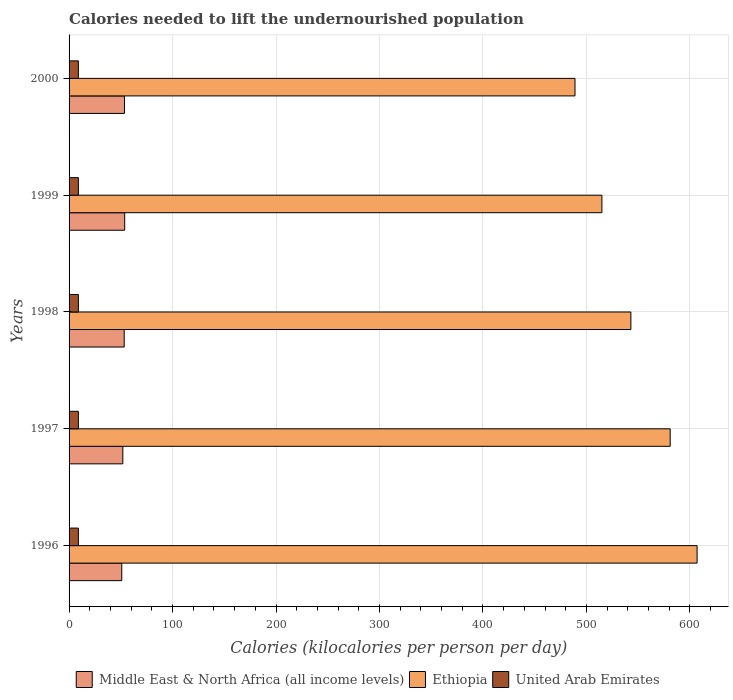Are the number of bars per tick equal to the number of legend labels?
Provide a short and direct response. Yes. Are the number of bars on each tick of the Y-axis equal?
Give a very brief answer. Yes. How many bars are there on the 4th tick from the top?
Keep it short and to the point. 3. What is the label of the 3rd group of bars from the top?
Make the answer very short. 1998. In how many cases, is the number of bars for a given year not equal to the number of legend labels?
Provide a short and direct response. 0. What is the total calories needed to lift the undernourished population in Ethiopia in 1998?
Keep it short and to the point. 543. Across all years, what is the maximum total calories needed to lift the undernourished population in United Arab Emirates?
Keep it short and to the point. 9. Across all years, what is the minimum total calories needed to lift the undernourished population in Middle East & North Africa (all income levels)?
Offer a terse response. 50.92. In which year was the total calories needed to lift the undernourished population in Middle East & North Africa (all income levels) minimum?
Your answer should be very brief. 1996. What is the total total calories needed to lift the undernourished population in United Arab Emirates in the graph?
Give a very brief answer. 45. What is the difference between the total calories needed to lift the undernourished population in Middle East & North Africa (all income levels) in 1997 and that in 1998?
Keep it short and to the point. -1.33. What is the difference between the total calories needed to lift the undernourished population in Ethiopia in 1998 and the total calories needed to lift the undernourished population in Middle East & North Africa (all income levels) in 1999?
Keep it short and to the point. 489.25. In the year 1997, what is the difference between the total calories needed to lift the undernourished population in Middle East & North Africa (all income levels) and total calories needed to lift the undernourished population in United Arab Emirates?
Your answer should be compact. 42.96. In how many years, is the total calories needed to lift the undernourished population in United Arab Emirates greater than 300 kilocalories?
Your answer should be compact. 0. What is the ratio of the total calories needed to lift the undernourished population in Middle East & North Africa (all income levels) in 1997 to that in 1998?
Your answer should be compact. 0.98. Is the total calories needed to lift the undernourished population in Middle East & North Africa (all income levels) in 1997 less than that in 1999?
Keep it short and to the point. Yes. Is the difference between the total calories needed to lift the undernourished population in Middle East & North Africa (all income levels) in 1997 and 2000 greater than the difference between the total calories needed to lift the undernourished population in United Arab Emirates in 1997 and 2000?
Your response must be concise. No. What is the difference between the highest and the second highest total calories needed to lift the undernourished population in Middle East & North Africa (all income levels)?
Your answer should be compact. 0.19. What is the difference between the highest and the lowest total calories needed to lift the undernourished population in Middle East & North Africa (all income levels)?
Keep it short and to the point. 2.83. What does the 3rd bar from the top in 1998 represents?
Ensure brevity in your answer.  Middle East & North Africa (all income levels). What does the 1st bar from the bottom in 2000 represents?
Provide a succinct answer. Middle East & North Africa (all income levels). Is it the case that in every year, the sum of the total calories needed to lift the undernourished population in Ethiopia and total calories needed to lift the undernourished population in Middle East & North Africa (all income levels) is greater than the total calories needed to lift the undernourished population in United Arab Emirates?
Offer a terse response. Yes. What is the difference between two consecutive major ticks on the X-axis?
Your answer should be compact. 100. Does the graph contain any zero values?
Your answer should be compact. No. How many legend labels are there?
Give a very brief answer. 3. How are the legend labels stacked?
Offer a terse response. Horizontal. What is the title of the graph?
Ensure brevity in your answer.  Calories needed to lift the undernourished population. Does "High income: nonOECD" appear as one of the legend labels in the graph?
Ensure brevity in your answer.  No. What is the label or title of the X-axis?
Keep it short and to the point. Calories (kilocalories per person per day). What is the Calories (kilocalories per person per day) of Middle East & North Africa (all income levels) in 1996?
Your response must be concise. 50.92. What is the Calories (kilocalories per person per day) in Ethiopia in 1996?
Your response must be concise. 607. What is the Calories (kilocalories per person per day) in United Arab Emirates in 1996?
Keep it short and to the point. 9. What is the Calories (kilocalories per person per day) of Middle East & North Africa (all income levels) in 1997?
Your response must be concise. 51.96. What is the Calories (kilocalories per person per day) of Ethiopia in 1997?
Your answer should be compact. 581. What is the Calories (kilocalories per person per day) of United Arab Emirates in 1997?
Your answer should be very brief. 9. What is the Calories (kilocalories per person per day) of Middle East & North Africa (all income levels) in 1998?
Keep it short and to the point. 53.29. What is the Calories (kilocalories per person per day) in Ethiopia in 1998?
Keep it short and to the point. 543. What is the Calories (kilocalories per person per day) in Middle East & North Africa (all income levels) in 1999?
Provide a short and direct response. 53.75. What is the Calories (kilocalories per person per day) of Ethiopia in 1999?
Your answer should be compact. 515. What is the Calories (kilocalories per person per day) in United Arab Emirates in 1999?
Keep it short and to the point. 9. What is the Calories (kilocalories per person per day) of Middle East & North Africa (all income levels) in 2000?
Give a very brief answer. 53.56. What is the Calories (kilocalories per person per day) of Ethiopia in 2000?
Offer a very short reply. 489. What is the Calories (kilocalories per person per day) in United Arab Emirates in 2000?
Keep it short and to the point. 9. Across all years, what is the maximum Calories (kilocalories per person per day) of Middle East & North Africa (all income levels)?
Give a very brief answer. 53.75. Across all years, what is the maximum Calories (kilocalories per person per day) of Ethiopia?
Offer a terse response. 607. Across all years, what is the maximum Calories (kilocalories per person per day) in United Arab Emirates?
Ensure brevity in your answer.  9. Across all years, what is the minimum Calories (kilocalories per person per day) of Middle East & North Africa (all income levels)?
Make the answer very short. 50.92. Across all years, what is the minimum Calories (kilocalories per person per day) in Ethiopia?
Make the answer very short. 489. Across all years, what is the minimum Calories (kilocalories per person per day) in United Arab Emirates?
Keep it short and to the point. 9. What is the total Calories (kilocalories per person per day) of Middle East & North Africa (all income levels) in the graph?
Your response must be concise. 263.48. What is the total Calories (kilocalories per person per day) of Ethiopia in the graph?
Make the answer very short. 2735. What is the total Calories (kilocalories per person per day) of United Arab Emirates in the graph?
Your answer should be very brief. 45. What is the difference between the Calories (kilocalories per person per day) in Middle East & North Africa (all income levels) in 1996 and that in 1997?
Your answer should be very brief. -1.04. What is the difference between the Calories (kilocalories per person per day) in Ethiopia in 1996 and that in 1997?
Give a very brief answer. 26. What is the difference between the Calories (kilocalories per person per day) in United Arab Emirates in 1996 and that in 1997?
Offer a terse response. 0. What is the difference between the Calories (kilocalories per person per day) of Middle East & North Africa (all income levels) in 1996 and that in 1998?
Provide a short and direct response. -2.36. What is the difference between the Calories (kilocalories per person per day) of Middle East & North Africa (all income levels) in 1996 and that in 1999?
Ensure brevity in your answer.  -2.83. What is the difference between the Calories (kilocalories per person per day) of Ethiopia in 1996 and that in 1999?
Provide a short and direct response. 92. What is the difference between the Calories (kilocalories per person per day) in Middle East & North Africa (all income levels) in 1996 and that in 2000?
Ensure brevity in your answer.  -2.63. What is the difference between the Calories (kilocalories per person per day) of Ethiopia in 1996 and that in 2000?
Ensure brevity in your answer.  118. What is the difference between the Calories (kilocalories per person per day) of United Arab Emirates in 1996 and that in 2000?
Ensure brevity in your answer.  0. What is the difference between the Calories (kilocalories per person per day) in Middle East & North Africa (all income levels) in 1997 and that in 1998?
Your response must be concise. -1.33. What is the difference between the Calories (kilocalories per person per day) in United Arab Emirates in 1997 and that in 1998?
Provide a succinct answer. 0. What is the difference between the Calories (kilocalories per person per day) of Middle East & North Africa (all income levels) in 1997 and that in 1999?
Give a very brief answer. -1.79. What is the difference between the Calories (kilocalories per person per day) in Ethiopia in 1997 and that in 1999?
Your response must be concise. 66. What is the difference between the Calories (kilocalories per person per day) in United Arab Emirates in 1997 and that in 1999?
Ensure brevity in your answer.  0. What is the difference between the Calories (kilocalories per person per day) of Middle East & North Africa (all income levels) in 1997 and that in 2000?
Offer a very short reply. -1.6. What is the difference between the Calories (kilocalories per person per day) in Ethiopia in 1997 and that in 2000?
Provide a succinct answer. 92. What is the difference between the Calories (kilocalories per person per day) in United Arab Emirates in 1997 and that in 2000?
Your answer should be very brief. 0. What is the difference between the Calories (kilocalories per person per day) of Middle East & North Africa (all income levels) in 1998 and that in 1999?
Keep it short and to the point. -0.46. What is the difference between the Calories (kilocalories per person per day) of Middle East & North Africa (all income levels) in 1998 and that in 2000?
Ensure brevity in your answer.  -0.27. What is the difference between the Calories (kilocalories per person per day) of United Arab Emirates in 1998 and that in 2000?
Your response must be concise. 0. What is the difference between the Calories (kilocalories per person per day) of Middle East & North Africa (all income levels) in 1999 and that in 2000?
Provide a short and direct response. 0.19. What is the difference between the Calories (kilocalories per person per day) in Ethiopia in 1999 and that in 2000?
Your response must be concise. 26. What is the difference between the Calories (kilocalories per person per day) of Middle East & North Africa (all income levels) in 1996 and the Calories (kilocalories per person per day) of Ethiopia in 1997?
Offer a terse response. -530.08. What is the difference between the Calories (kilocalories per person per day) in Middle East & North Africa (all income levels) in 1996 and the Calories (kilocalories per person per day) in United Arab Emirates in 1997?
Your response must be concise. 41.92. What is the difference between the Calories (kilocalories per person per day) of Ethiopia in 1996 and the Calories (kilocalories per person per day) of United Arab Emirates in 1997?
Offer a very short reply. 598. What is the difference between the Calories (kilocalories per person per day) in Middle East & North Africa (all income levels) in 1996 and the Calories (kilocalories per person per day) in Ethiopia in 1998?
Your answer should be compact. -492.08. What is the difference between the Calories (kilocalories per person per day) in Middle East & North Africa (all income levels) in 1996 and the Calories (kilocalories per person per day) in United Arab Emirates in 1998?
Ensure brevity in your answer.  41.92. What is the difference between the Calories (kilocalories per person per day) in Ethiopia in 1996 and the Calories (kilocalories per person per day) in United Arab Emirates in 1998?
Your answer should be very brief. 598. What is the difference between the Calories (kilocalories per person per day) in Middle East & North Africa (all income levels) in 1996 and the Calories (kilocalories per person per day) in Ethiopia in 1999?
Your answer should be compact. -464.08. What is the difference between the Calories (kilocalories per person per day) of Middle East & North Africa (all income levels) in 1996 and the Calories (kilocalories per person per day) of United Arab Emirates in 1999?
Provide a short and direct response. 41.92. What is the difference between the Calories (kilocalories per person per day) in Ethiopia in 1996 and the Calories (kilocalories per person per day) in United Arab Emirates in 1999?
Your response must be concise. 598. What is the difference between the Calories (kilocalories per person per day) in Middle East & North Africa (all income levels) in 1996 and the Calories (kilocalories per person per day) in Ethiopia in 2000?
Ensure brevity in your answer.  -438.08. What is the difference between the Calories (kilocalories per person per day) in Middle East & North Africa (all income levels) in 1996 and the Calories (kilocalories per person per day) in United Arab Emirates in 2000?
Ensure brevity in your answer.  41.92. What is the difference between the Calories (kilocalories per person per day) in Ethiopia in 1996 and the Calories (kilocalories per person per day) in United Arab Emirates in 2000?
Make the answer very short. 598. What is the difference between the Calories (kilocalories per person per day) of Middle East & North Africa (all income levels) in 1997 and the Calories (kilocalories per person per day) of Ethiopia in 1998?
Your answer should be very brief. -491.04. What is the difference between the Calories (kilocalories per person per day) of Middle East & North Africa (all income levels) in 1997 and the Calories (kilocalories per person per day) of United Arab Emirates in 1998?
Give a very brief answer. 42.96. What is the difference between the Calories (kilocalories per person per day) of Ethiopia in 1997 and the Calories (kilocalories per person per day) of United Arab Emirates in 1998?
Your response must be concise. 572. What is the difference between the Calories (kilocalories per person per day) in Middle East & North Africa (all income levels) in 1997 and the Calories (kilocalories per person per day) in Ethiopia in 1999?
Keep it short and to the point. -463.04. What is the difference between the Calories (kilocalories per person per day) in Middle East & North Africa (all income levels) in 1997 and the Calories (kilocalories per person per day) in United Arab Emirates in 1999?
Keep it short and to the point. 42.96. What is the difference between the Calories (kilocalories per person per day) in Ethiopia in 1997 and the Calories (kilocalories per person per day) in United Arab Emirates in 1999?
Make the answer very short. 572. What is the difference between the Calories (kilocalories per person per day) of Middle East & North Africa (all income levels) in 1997 and the Calories (kilocalories per person per day) of Ethiopia in 2000?
Your response must be concise. -437.04. What is the difference between the Calories (kilocalories per person per day) in Middle East & North Africa (all income levels) in 1997 and the Calories (kilocalories per person per day) in United Arab Emirates in 2000?
Ensure brevity in your answer.  42.96. What is the difference between the Calories (kilocalories per person per day) of Ethiopia in 1997 and the Calories (kilocalories per person per day) of United Arab Emirates in 2000?
Your answer should be compact. 572. What is the difference between the Calories (kilocalories per person per day) in Middle East & North Africa (all income levels) in 1998 and the Calories (kilocalories per person per day) in Ethiopia in 1999?
Make the answer very short. -461.71. What is the difference between the Calories (kilocalories per person per day) of Middle East & North Africa (all income levels) in 1998 and the Calories (kilocalories per person per day) of United Arab Emirates in 1999?
Ensure brevity in your answer.  44.29. What is the difference between the Calories (kilocalories per person per day) in Ethiopia in 1998 and the Calories (kilocalories per person per day) in United Arab Emirates in 1999?
Offer a very short reply. 534. What is the difference between the Calories (kilocalories per person per day) of Middle East & North Africa (all income levels) in 1998 and the Calories (kilocalories per person per day) of Ethiopia in 2000?
Keep it short and to the point. -435.71. What is the difference between the Calories (kilocalories per person per day) in Middle East & North Africa (all income levels) in 1998 and the Calories (kilocalories per person per day) in United Arab Emirates in 2000?
Offer a terse response. 44.29. What is the difference between the Calories (kilocalories per person per day) in Ethiopia in 1998 and the Calories (kilocalories per person per day) in United Arab Emirates in 2000?
Offer a terse response. 534. What is the difference between the Calories (kilocalories per person per day) of Middle East & North Africa (all income levels) in 1999 and the Calories (kilocalories per person per day) of Ethiopia in 2000?
Offer a very short reply. -435.25. What is the difference between the Calories (kilocalories per person per day) of Middle East & North Africa (all income levels) in 1999 and the Calories (kilocalories per person per day) of United Arab Emirates in 2000?
Your answer should be very brief. 44.75. What is the difference between the Calories (kilocalories per person per day) in Ethiopia in 1999 and the Calories (kilocalories per person per day) in United Arab Emirates in 2000?
Provide a short and direct response. 506. What is the average Calories (kilocalories per person per day) in Middle East & North Africa (all income levels) per year?
Offer a very short reply. 52.7. What is the average Calories (kilocalories per person per day) in Ethiopia per year?
Provide a short and direct response. 547. In the year 1996, what is the difference between the Calories (kilocalories per person per day) of Middle East & North Africa (all income levels) and Calories (kilocalories per person per day) of Ethiopia?
Keep it short and to the point. -556.08. In the year 1996, what is the difference between the Calories (kilocalories per person per day) of Middle East & North Africa (all income levels) and Calories (kilocalories per person per day) of United Arab Emirates?
Provide a succinct answer. 41.92. In the year 1996, what is the difference between the Calories (kilocalories per person per day) of Ethiopia and Calories (kilocalories per person per day) of United Arab Emirates?
Offer a very short reply. 598. In the year 1997, what is the difference between the Calories (kilocalories per person per day) in Middle East & North Africa (all income levels) and Calories (kilocalories per person per day) in Ethiopia?
Keep it short and to the point. -529.04. In the year 1997, what is the difference between the Calories (kilocalories per person per day) in Middle East & North Africa (all income levels) and Calories (kilocalories per person per day) in United Arab Emirates?
Provide a short and direct response. 42.96. In the year 1997, what is the difference between the Calories (kilocalories per person per day) in Ethiopia and Calories (kilocalories per person per day) in United Arab Emirates?
Provide a succinct answer. 572. In the year 1998, what is the difference between the Calories (kilocalories per person per day) of Middle East & North Africa (all income levels) and Calories (kilocalories per person per day) of Ethiopia?
Offer a very short reply. -489.71. In the year 1998, what is the difference between the Calories (kilocalories per person per day) of Middle East & North Africa (all income levels) and Calories (kilocalories per person per day) of United Arab Emirates?
Make the answer very short. 44.29. In the year 1998, what is the difference between the Calories (kilocalories per person per day) in Ethiopia and Calories (kilocalories per person per day) in United Arab Emirates?
Your answer should be compact. 534. In the year 1999, what is the difference between the Calories (kilocalories per person per day) in Middle East & North Africa (all income levels) and Calories (kilocalories per person per day) in Ethiopia?
Offer a very short reply. -461.25. In the year 1999, what is the difference between the Calories (kilocalories per person per day) of Middle East & North Africa (all income levels) and Calories (kilocalories per person per day) of United Arab Emirates?
Offer a very short reply. 44.75. In the year 1999, what is the difference between the Calories (kilocalories per person per day) in Ethiopia and Calories (kilocalories per person per day) in United Arab Emirates?
Your answer should be compact. 506. In the year 2000, what is the difference between the Calories (kilocalories per person per day) of Middle East & North Africa (all income levels) and Calories (kilocalories per person per day) of Ethiopia?
Offer a terse response. -435.44. In the year 2000, what is the difference between the Calories (kilocalories per person per day) of Middle East & North Africa (all income levels) and Calories (kilocalories per person per day) of United Arab Emirates?
Give a very brief answer. 44.56. In the year 2000, what is the difference between the Calories (kilocalories per person per day) of Ethiopia and Calories (kilocalories per person per day) of United Arab Emirates?
Your response must be concise. 480. What is the ratio of the Calories (kilocalories per person per day) in Ethiopia in 1996 to that in 1997?
Give a very brief answer. 1.04. What is the ratio of the Calories (kilocalories per person per day) of Middle East & North Africa (all income levels) in 1996 to that in 1998?
Your answer should be very brief. 0.96. What is the ratio of the Calories (kilocalories per person per day) of Ethiopia in 1996 to that in 1998?
Keep it short and to the point. 1.12. What is the ratio of the Calories (kilocalories per person per day) of Middle East & North Africa (all income levels) in 1996 to that in 1999?
Give a very brief answer. 0.95. What is the ratio of the Calories (kilocalories per person per day) of Ethiopia in 1996 to that in 1999?
Provide a short and direct response. 1.18. What is the ratio of the Calories (kilocalories per person per day) in United Arab Emirates in 1996 to that in 1999?
Provide a short and direct response. 1. What is the ratio of the Calories (kilocalories per person per day) of Middle East & North Africa (all income levels) in 1996 to that in 2000?
Your answer should be compact. 0.95. What is the ratio of the Calories (kilocalories per person per day) in Ethiopia in 1996 to that in 2000?
Your answer should be compact. 1.24. What is the ratio of the Calories (kilocalories per person per day) of Middle East & North Africa (all income levels) in 1997 to that in 1998?
Your answer should be compact. 0.98. What is the ratio of the Calories (kilocalories per person per day) in Ethiopia in 1997 to that in 1998?
Offer a terse response. 1.07. What is the ratio of the Calories (kilocalories per person per day) in United Arab Emirates in 1997 to that in 1998?
Offer a terse response. 1. What is the ratio of the Calories (kilocalories per person per day) of Middle East & North Africa (all income levels) in 1997 to that in 1999?
Your answer should be very brief. 0.97. What is the ratio of the Calories (kilocalories per person per day) in Ethiopia in 1997 to that in 1999?
Make the answer very short. 1.13. What is the ratio of the Calories (kilocalories per person per day) of United Arab Emirates in 1997 to that in 1999?
Offer a terse response. 1. What is the ratio of the Calories (kilocalories per person per day) of Middle East & North Africa (all income levels) in 1997 to that in 2000?
Provide a short and direct response. 0.97. What is the ratio of the Calories (kilocalories per person per day) of Ethiopia in 1997 to that in 2000?
Offer a very short reply. 1.19. What is the ratio of the Calories (kilocalories per person per day) of Ethiopia in 1998 to that in 1999?
Offer a very short reply. 1.05. What is the ratio of the Calories (kilocalories per person per day) in United Arab Emirates in 1998 to that in 1999?
Give a very brief answer. 1. What is the ratio of the Calories (kilocalories per person per day) in Ethiopia in 1998 to that in 2000?
Provide a succinct answer. 1.11. What is the ratio of the Calories (kilocalories per person per day) in United Arab Emirates in 1998 to that in 2000?
Your answer should be compact. 1. What is the ratio of the Calories (kilocalories per person per day) in Ethiopia in 1999 to that in 2000?
Your answer should be very brief. 1.05. What is the difference between the highest and the second highest Calories (kilocalories per person per day) in Middle East & North Africa (all income levels)?
Offer a very short reply. 0.19. What is the difference between the highest and the lowest Calories (kilocalories per person per day) of Middle East & North Africa (all income levels)?
Provide a short and direct response. 2.83. What is the difference between the highest and the lowest Calories (kilocalories per person per day) of Ethiopia?
Provide a short and direct response. 118. 